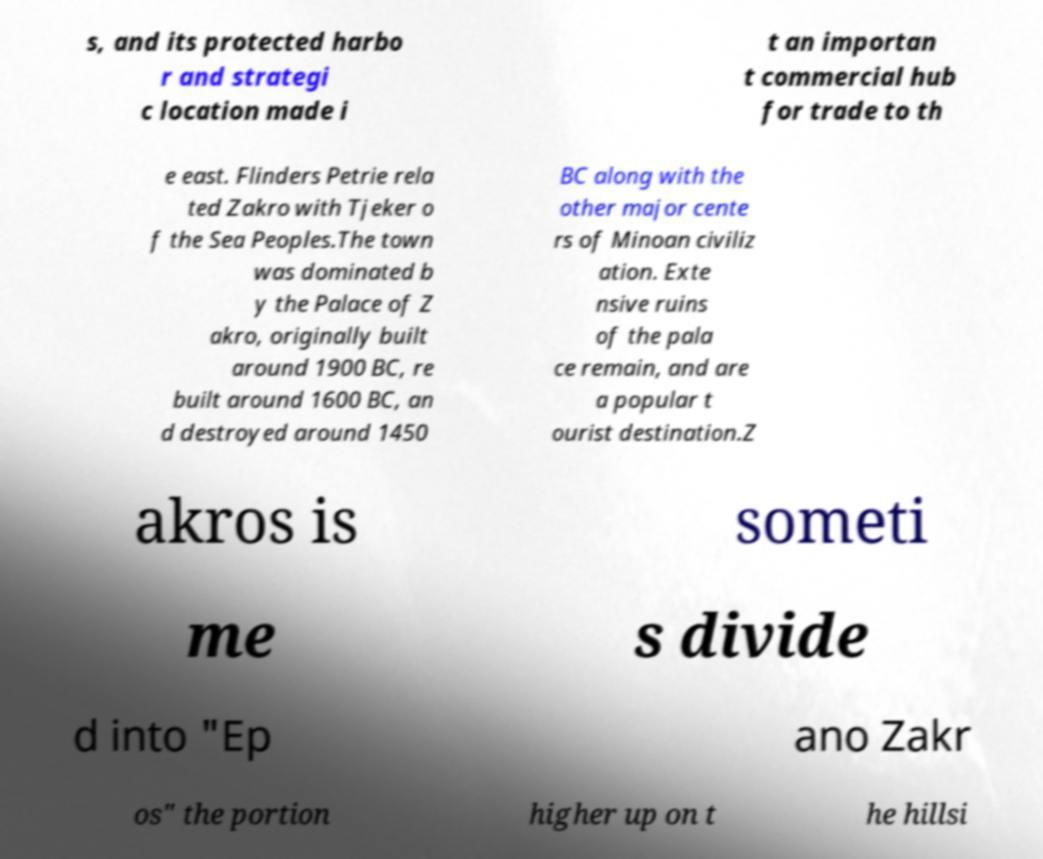Please identify and transcribe the text found in this image. s, and its protected harbo r and strategi c location made i t an importan t commercial hub for trade to th e east. Flinders Petrie rela ted Zakro with Tjeker o f the Sea Peoples.The town was dominated b y the Palace of Z akro, originally built around 1900 BC, re built around 1600 BC, an d destroyed around 1450 BC along with the other major cente rs of Minoan civiliz ation. Exte nsive ruins of the pala ce remain, and are a popular t ourist destination.Z akros is someti me s divide d into "Ep ano Zakr os" the portion higher up on t he hillsi 